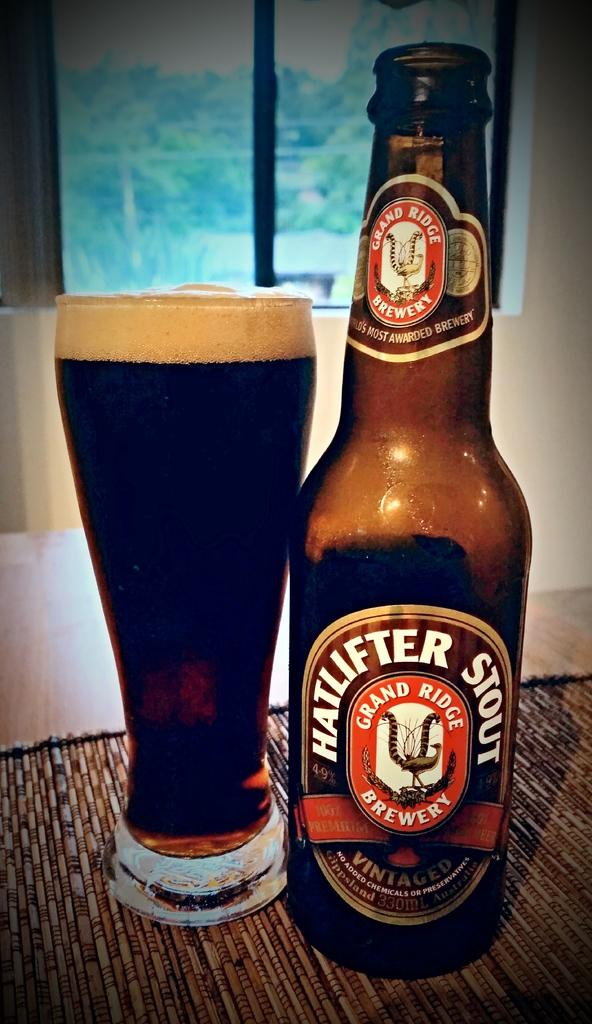<image>
Describe the image concisely. Hatlifter Stout Beer brewed from the Grand Ridge Brewery. 